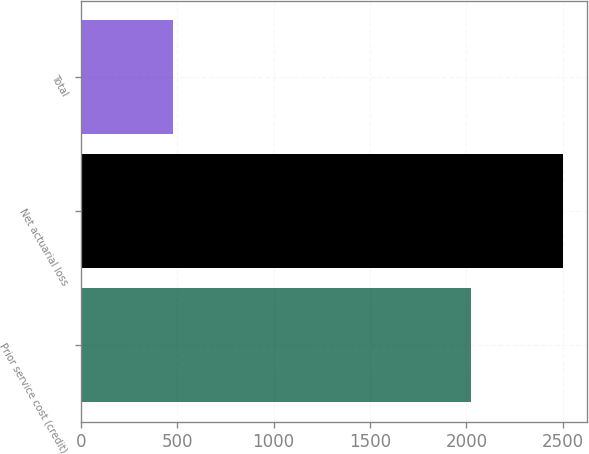Convert chart to OTSL. <chart><loc_0><loc_0><loc_500><loc_500><bar_chart><fcel>Prior service cost (credit)<fcel>Net actuarial loss<fcel>Total<nl><fcel>2025<fcel>2501<fcel>476<nl></chart> 